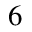<formula> <loc_0><loc_0><loc_500><loc_500>_ { 6 }</formula> 